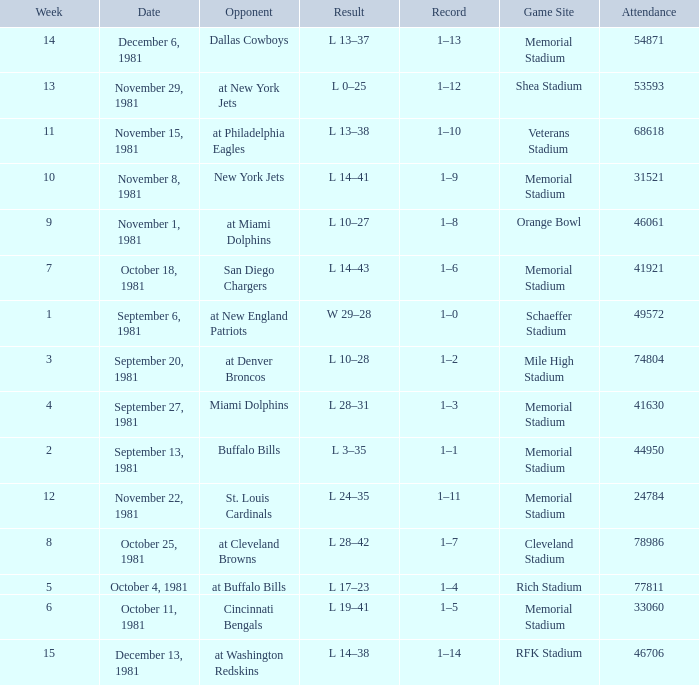When 74804 is the attendance what week is it? 3.0. 